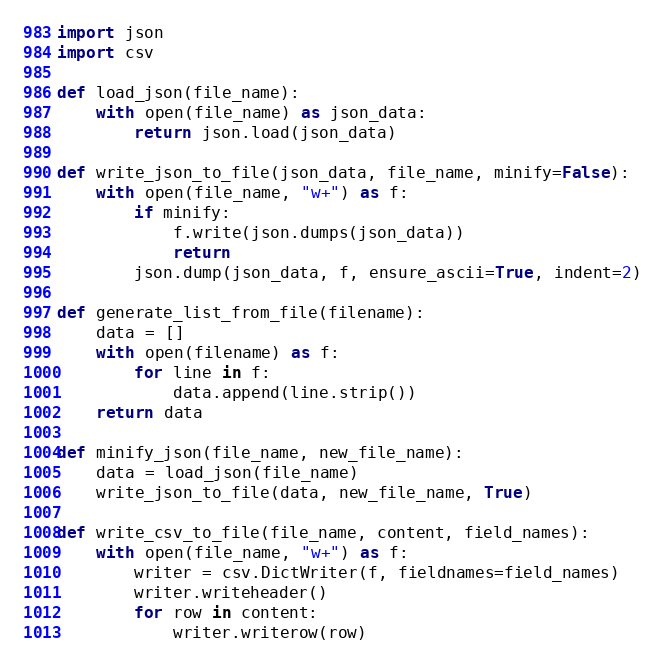Convert code to text. <code><loc_0><loc_0><loc_500><loc_500><_Python_>import json
import csv

def load_json(file_name):
    with open(file_name) as json_data:
        return json.load(json_data)

def write_json_to_file(json_data, file_name, minify=False):
    with open(file_name, "w+") as f:
        if minify:
            f.write(json.dumps(json_data))
            return
        json.dump(json_data, f, ensure_ascii=True, indent=2)

def generate_list_from_file(filename):
    data = []
    with open(filename) as f:
        for line in f:
            data.append(line.strip())
    return data

def minify_json(file_name, new_file_name):
    data = load_json(file_name)
    write_json_to_file(data, new_file_name, True)

def write_csv_to_file(file_name, content, field_names):
    with open(file_name, "w+") as f:
        writer = csv.DictWriter(f, fieldnames=field_names)
        writer.writeheader()
        for row in content:
            writer.writerow(row)</code> 